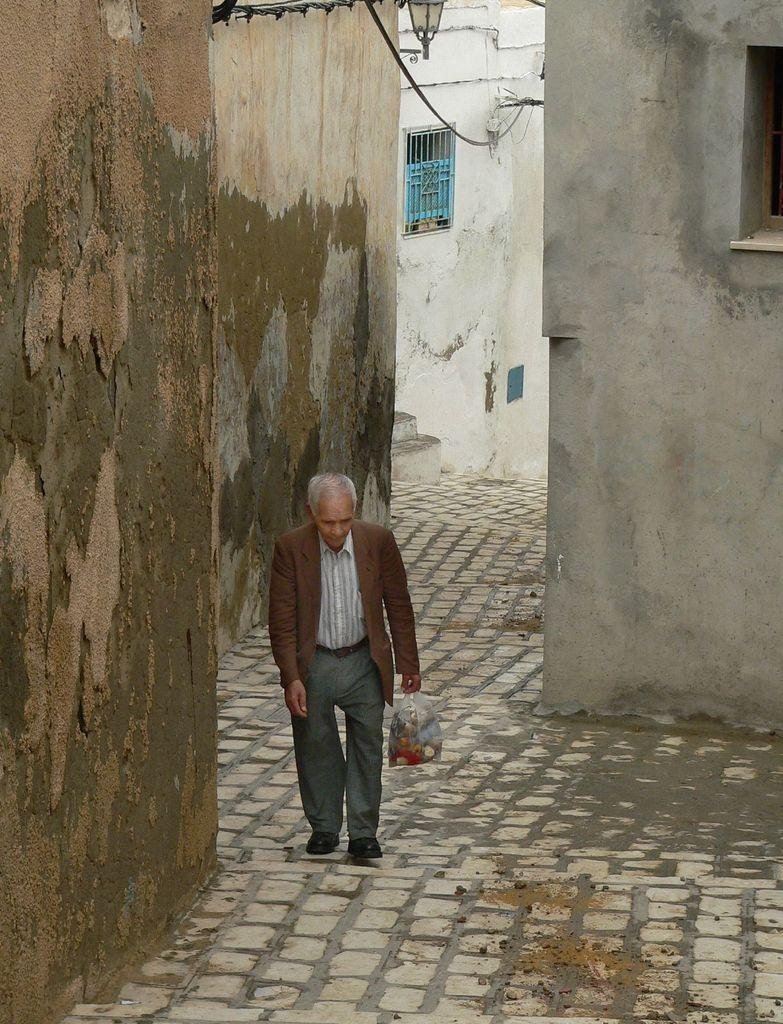What type of structures are visible in the image? There are buildings in the image. What is the man in the image doing? The man is walking in the image. What is the man holding in his hand? The man is holding a carry bag in his hand. Where is the light located in the image? The light is on the wall on the left side of the image. What color is the crayon that the man is using to draw on the buildings in the image? There is no crayon or drawing activity present in the image. How can we help the man in the image? There is no indication in the image that the man needs help, and we cannot provide assistance based on the information provided. 